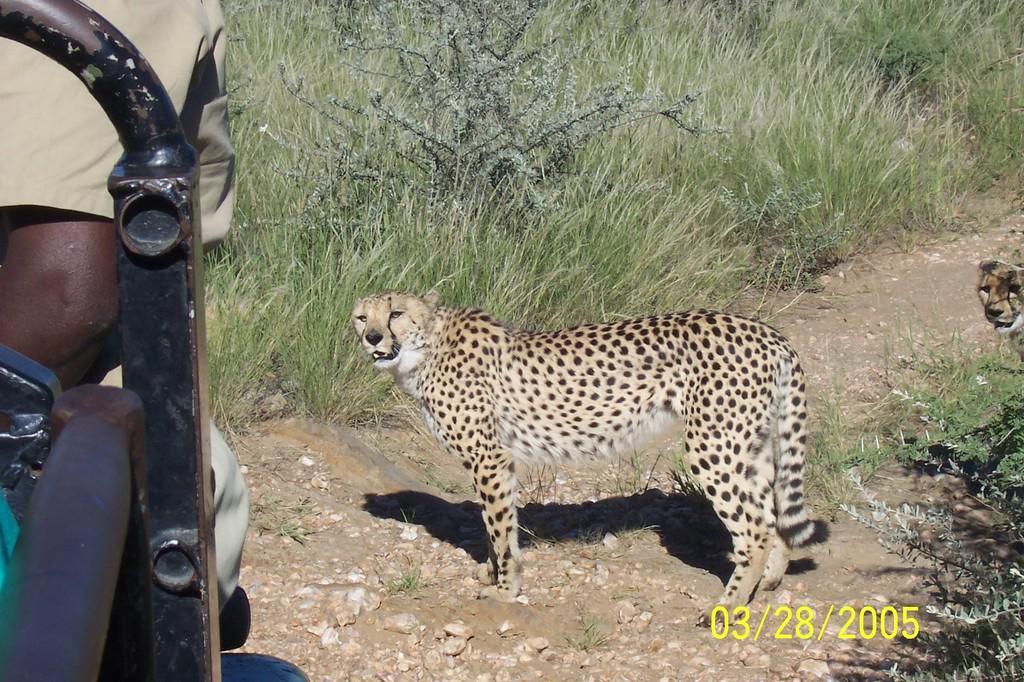In one or two sentences, can you explain what this image depicts? In this picture I can see that there are two leopards standing here and there is a person sitting inside the car and in the background there are grass, plants, stones and soil. 